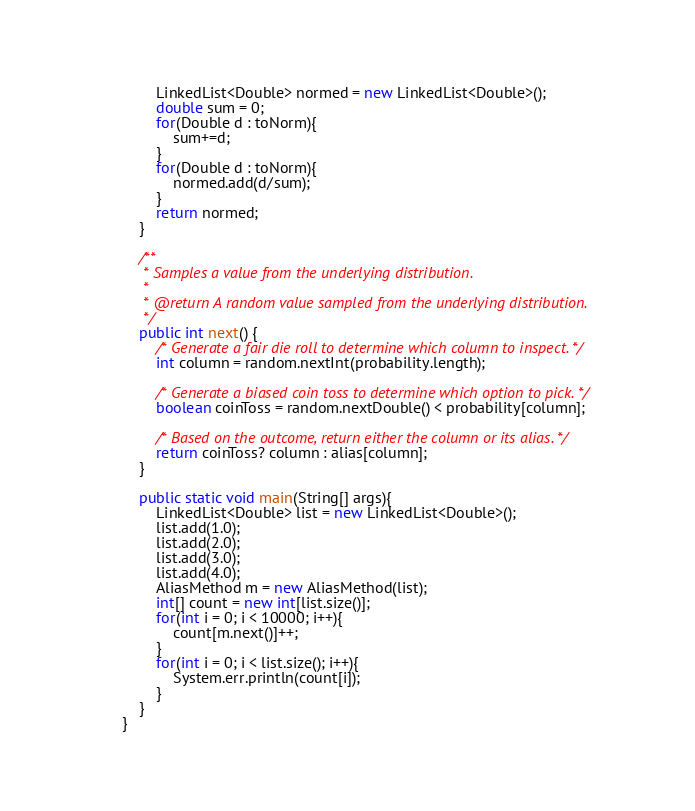<code> <loc_0><loc_0><loc_500><loc_500><_Java_>    	LinkedList<Double> normed = new LinkedList<Double>();
    	double sum = 0;
    	for(Double d : toNorm){
    		sum+=d;
    	}
    	for(Double d : toNorm){
    		normed.add(d/sum);
    	}    	
    	return normed;
    }

    /**
     * Samples a value from the underlying distribution.
     *
     * @return A random value sampled from the underlying distribution.
     */
    public int next() {
        /* Generate a fair die roll to determine which column to inspect. */
        int column = random.nextInt(probability.length);

        /* Generate a biased coin toss to determine which option to pick. */
        boolean coinToss = random.nextDouble() < probability[column];

        /* Based on the outcome, return either the column or its alias. */
        return coinToss? column : alias[column];
    }
    
    public static void main(String[] args){
    	LinkedList<Double> list = new LinkedList<Double>();
    	list.add(1.0);
    	list.add(2.0);
    	list.add(3.0);
    	list.add(4.0);
    	AliasMethod m = new AliasMethod(list);
    	int[] count = new int[list.size()];
    	for(int i = 0; i < 10000; i++){
        	count[m.next()]++;    		
    	}
    	for(int i = 0; i < list.size(); i++){
    		System.err.println(count[i]);
    	}
    }
}
</code> 